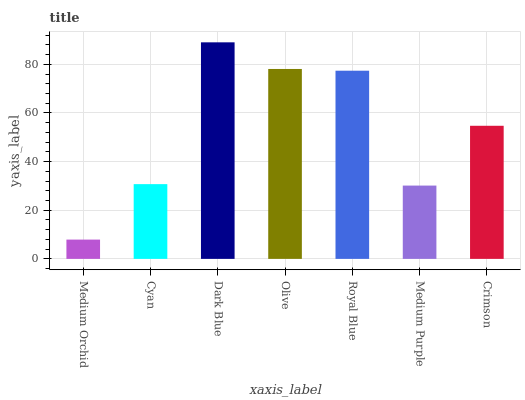Is Medium Orchid the minimum?
Answer yes or no. Yes. Is Dark Blue the maximum?
Answer yes or no. Yes. Is Cyan the minimum?
Answer yes or no. No. Is Cyan the maximum?
Answer yes or no. No. Is Cyan greater than Medium Orchid?
Answer yes or no. Yes. Is Medium Orchid less than Cyan?
Answer yes or no. Yes. Is Medium Orchid greater than Cyan?
Answer yes or no. No. Is Cyan less than Medium Orchid?
Answer yes or no. No. Is Crimson the high median?
Answer yes or no. Yes. Is Crimson the low median?
Answer yes or no. Yes. Is Medium Purple the high median?
Answer yes or no. No. Is Medium Orchid the low median?
Answer yes or no. No. 